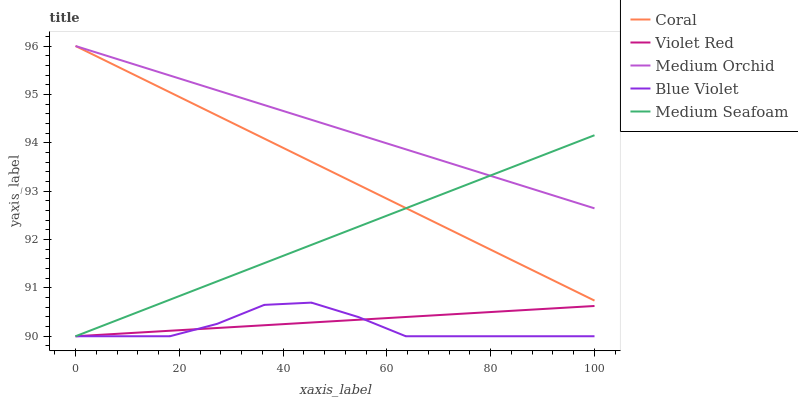Does Blue Violet have the minimum area under the curve?
Answer yes or no. Yes. Does Medium Orchid have the maximum area under the curve?
Answer yes or no. Yes. Does Violet Red have the minimum area under the curve?
Answer yes or no. No. Does Violet Red have the maximum area under the curve?
Answer yes or no. No. Is Coral the smoothest?
Answer yes or no. Yes. Is Blue Violet the roughest?
Answer yes or no. Yes. Is Medium Orchid the smoothest?
Answer yes or no. No. Is Medium Orchid the roughest?
Answer yes or no. No. Does Violet Red have the lowest value?
Answer yes or no. Yes. Does Medium Orchid have the lowest value?
Answer yes or no. No. Does Medium Orchid have the highest value?
Answer yes or no. Yes. Does Violet Red have the highest value?
Answer yes or no. No. Is Blue Violet less than Medium Orchid?
Answer yes or no. Yes. Is Coral greater than Blue Violet?
Answer yes or no. Yes. Does Medium Orchid intersect Medium Seafoam?
Answer yes or no. Yes. Is Medium Orchid less than Medium Seafoam?
Answer yes or no. No. Is Medium Orchid greater than Medium Seafoam?
Answer yes or no. No. Does Blue Violet intersect Medium Orchid?
Answer yes or no. No. 